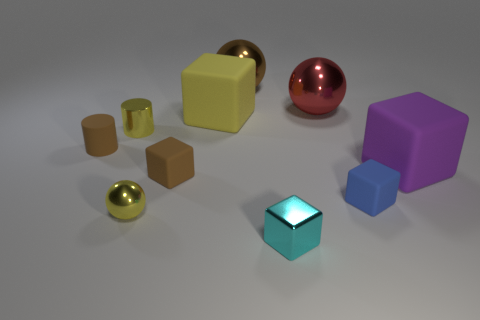Subtract all yellow blocks. How many blocks are left? 4 Subtract 2 blocks. How many blocks are left? 3 Subtract all yellow rubber cubes. How many cubes are left? 4 Subtract all brown blocks. Subtract all green spheres. How many blocks are left? 4 Subtract all cylinders. How many objects are left? 8 Add 6 tiny yellow shiny balls. How many tiny yellow shiny balls exist? 7 Subtract 0 purple balls. How many objects are left? 10 Subtract all large green things. Subtract all balls. How many objects are left? 7 Add 1 large metal objects. How many large metal objects are left? 3 